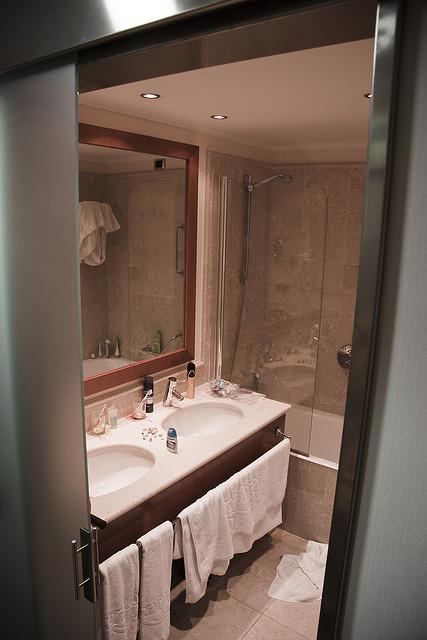What is hanging on the hook shown in the mirror?
Quick response, please. Towel. Was this photo taken at someone's house or a hotel?
Short answer required. Hotel. Does the bathroom look clean?
Short answer required. Yes. How many sinks are in the picture?
Write a very short answer. 2. Does it look like someone has been showering?
Give a very brief answer. Yes. Is the bathroom clean?
Quick response, please. No. Is there any soap in the bathroom?
Be succinct. Yes. Are all the towels hung up?
Be succinct. No. How many towels are hanging on the towel rack?
Give a very brief answer. 3. Is this bathroom clean?
Concise answer only. No. Is the bathroom organized?
Write a very short answer. No. Where are the lights installed?
Short answer required. Ceiling. 